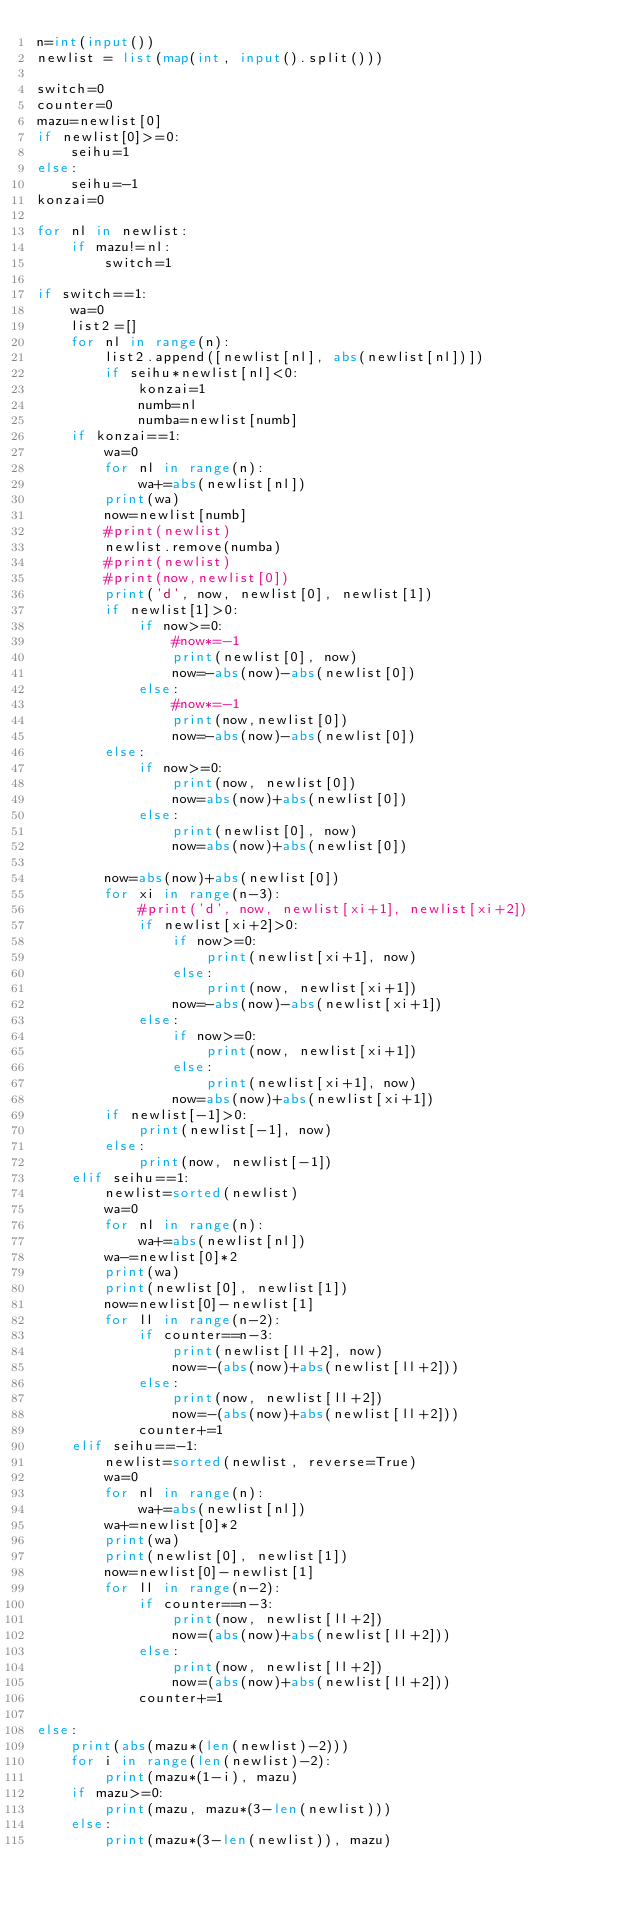<code> <loc_0><loc_0><loc_500><loc_500><_Python_>n=int(input())
newlist = list(map(int, input().split()))

switch=0
counter=0
mazu=newlist[0]
if newlist[0]>=0:
    seihu=1
else:
    seihu=-1
konzai=0

for nl in newlist:
    if mazu!=nl:
        switch=1

if switch==1:
    wa=0
    list2=[]
    for nl in range(n):
        list2.append([newlist[nl], abs(newlist[nl])])
        if seihu*newlist[nl]<0:
            konzai=1
            numb=nl
            numba=newlist[numb]
    if konzai==1:
        wa=0
        for nl in range(n):
            wa+=abs(newlist[nl])
        print(wa)
        now=newlist[numb]
        #print(newlist)
        newlist.remove(numba)
        #print(newlist)
        #print(now,newlist[0])
        print('d', now, newlist[0], newlist[1])
        if newlist[1]>0:
            if now>=0:
                #now*=-1
                print(newlist[0], now)
                now=-abs(now)-abs(newlist[0])
            else:
                #now*=-1
                print(now,newlist[0])
                now=-abs(now)-abs(newlist[0])
        else:
            if now>=0:
                print(now, newlist[0])
                now=abs(now)+abs(newlist[0])
            else:
                print(newlist[0], now)
                now=abs(now)+abs(newlist[0])
            
        now=abs(now)+abs(newlist[0])
        for xi in range(n-3):
            #print('d', now, newlist[xi+1], newlist[xi+2])
            if newlist[xi+2]>0:
                if now>=0:
                    print(newlist[xi+1], now)
                else:
                    print(now, newlist[xi+1])
                now=-abs(now)-abs(newlist[xi+1])
            else:
                if now>=0:
                    print(now, newlist[xi+1])
                else:
                    print(newlist[xi+1], now)
                now=abs(now)+abs(newlist[xi+1])
        if newlist[-1]>0:
            print(newlist[-1], now)
        else:
            print(now, newlist[-1])
    elif seihu==1:
        newlist=sorted(newlist)
        wa=0
        for nl in range(n):
            wa+=abs(newlist[nl])
        wa-=newlist[0]*2
        print(wa)
        print(newlist[0], newlist[1])
        now=newlist[0]-newlist[1]
        for ll in range(n-2):
            if counter==n-3:
                print(newlist[ll+2], now)
                now=-(abs(now)+abs(newlist[ll+2]))
            else:
                print(now, newlist[ll+2])
                now=-(abs(now)+abs(newlist[ll+2]))
            counter+=1
    elif seihu==-1:
        newlist=sorted(newlist, reverse=True)
        wa=0
        for nl in range(n):
            wa+=abs(newlist[nl])
        wa+=newlist[0]*2
        print(wa)
        print(newlist[0], newlist[1])
        now=newlist[0]-newlist[1]
        for ll in range(n-2):
            if counter==n-3:
                print(now, newlist[ll+2])
                now=(abs(now)+abs(newlist[ll+2]))
            else:
                print(now, newlist[ll+2])
                now=(abs(now)+abs(newlist[ll+2]))
            counter+=1
    
else:
    print(abs(mazu*(len(newlist)-2)))
    for i in range(len(newlist)-2):
        print(mazu*(1-i), mazu)
    if mazu>=0:
        print(mazu, mazu*(3-len(newlist)))
    else:
        print(mazu*(3-len(newlist)), mazu)</code> 